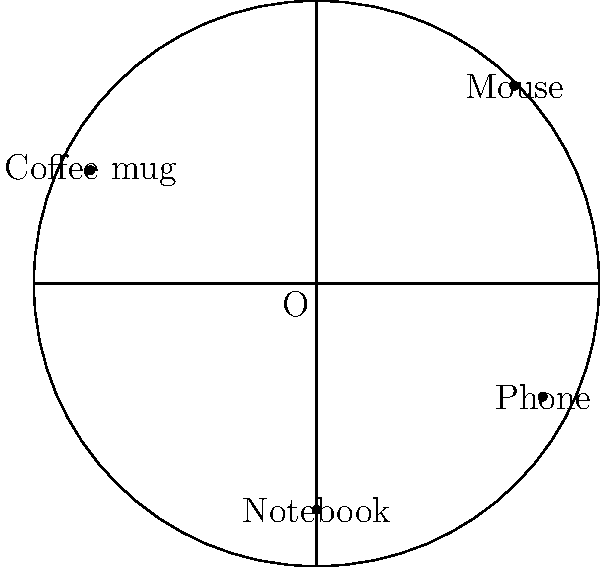A compact and adjustable laptop desk has a circular surface with a radius of 5 units. Four accessories are placed on the desk: a mouse at $(3.5, 3.5)$, a coffee mug at $(-4, 2)$, a notebook at $(0, -4)$, and a phone at $(4, -2)$. Which accessory is placed closest to the edge of the desk surface when expressed in polar coordinates $(r, \theta)$? To solve this problem, we need to follow these steps:

1. Convert the Cartesian coordinates of each accessory to polar coordinates $(r, \theta)$.
2. Compare the $r$ values to determine which is closest to the desk's radius (5 units).

For each accessory:

Mouse $(3.5, 3.5)$:
$r = \sqrt{3.5^2 + 3.5^2} = \sqrt{24.5} \approx 4.95$
$\theta = \arctan(\frac{3.5}{3.5}) = 45°$

Coffee mug $(-4, 2)$:
$r = \sqrt{(-4)^2 + 2^2} = \sqrt{20} \approx 4.47$
$\theta = \arctan(\frac{2}{-4}) + 180° = 153.4°$

Notebook $(0, -4)$:
$r = \sqrt{0^2 + (-4)^2} = 4$
$\theta = 270°$

Phone $(4, -2)$:
$r = \sqrt{4^2 + (-2)^2} = \sqrt{20} \approx 4.47$
$\theta = \arctan(\frac{-2}{4}) + 360° = 333.4°$

Comparing the $r$ values:
Mouse: 4.95
Coffee mug: 4.47
Notebook: 4.00
Phone: 4.47

The mouse has the largest $r$ value (4.95), which is closest to the desk's radius of 5 units.
Answer: Mouse $(4.95, 45°)$ 